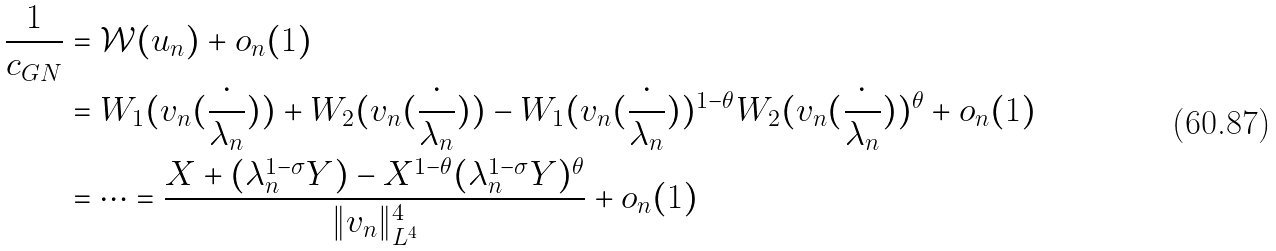Convert formula to latex. <formula><loc_0><loc_0><loc_500><loc_500>\frac { 1 } { c _ { G N } } & = \mathcal { W } ( u _ { n } ) + o _ { n } ( 1 ) \\ & = W _ { 1 } ( v _ { n } ( \frac { \cdot } { \lambda _ { n } } ) ) + W _ { 2 } ( v _ { n } ( \frac { \cdot } { \lambda _ { n } } ) ) - W _ { 1 } ( v _ { n } ( \frac { \cdot } { \lambda _ { n } } ) ) ^ { 1 - \theta } W _ { 2 } ( v _ { n } ( \frac { \cdot } { \lambda _ { n } } ) ) ^ { \theta } + o _ { n } ( 1 ) \\ & = \cdots = \frac { X + ( \lambda _ { n } ^ { 1 - \sigma } Y ) - X ^ { 1 - \theta } ( \lambda _ { n } ^ { 1 - \sigma } Y ) ^ { \theta } } { \| v _ { n } \| _ { L ^ { 4 } } ^ { 4 } } + o _ { n } ( 1 )</formula> 